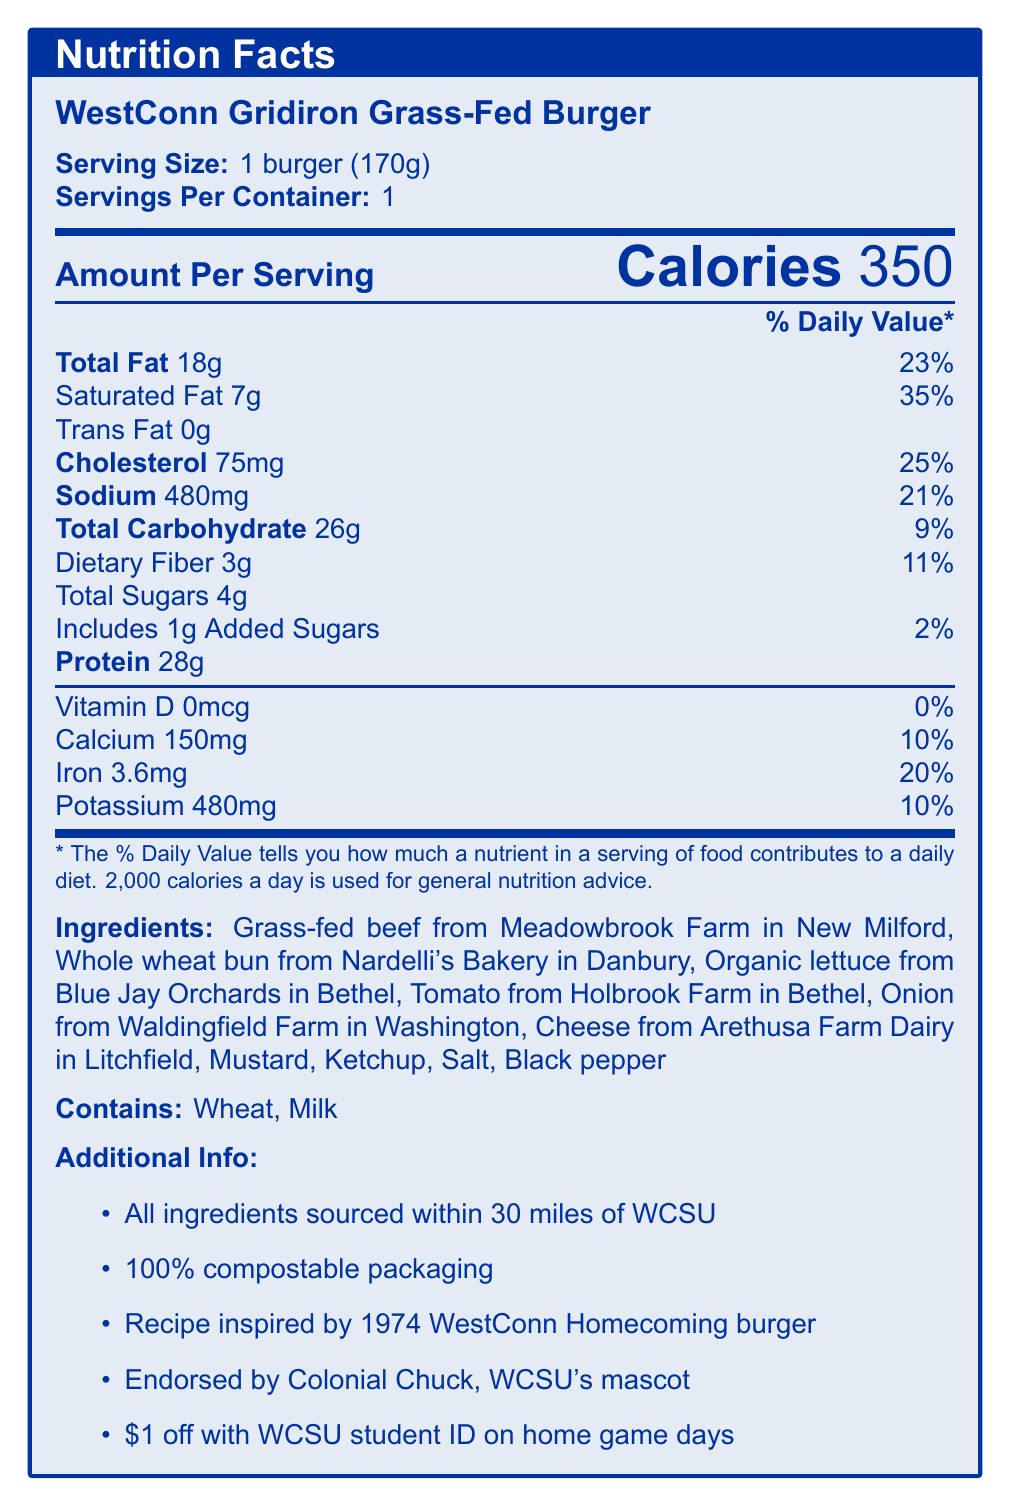what is the serving size of the WestConn Gridiron Grass-Fed Burger? The document states that the serving size is 1 burger weighing 170 grams.
Answer: 1 burger (170g) how many calories are in one serving of the WestConn Gridiron Grass-Fed Burger? The document indicates there are 350 calories in one serving.
Answer: 350 how much total fat does the burger contain? The document lists the total fat content as 18 grams.
Answer: 18g what are the ingredients of the WestConn Gridiron Grass-Fed Burger? The document details all the ingredients used in the burger.
Answer: Grass-fed beef from Meadowbrook Farm in New Milford, Whole wheat bun from Nardelli's Bakery in Danbury, Organic lettuce from Blue Jay Orchards in Bethel, Tomato from Holbrook Farm in Bethel, Onion from Waldingfield Farm in Washington, Cheese from Arethusa Farm Dairy in Litchfield, Mustard, Ketchup, Salt, Black pepper what allergens are present in the WestConn Gridiron Grass-Fed Burger? The document specifies that the allergens in the burger are wheat and milk.
Answer: Wheat, Milk how much protein does the burger contain per serving? The document provides the amount of protein per serving, which is 28 grams.
Answer: 28g what percentage of the daily value of saturated fat does the burger provide? A. 23% B. 35% C. 21% D. 2% The document indicates that the saturated fat content is 7 grams, which is 35% of the daily value.
Answer: B. 35% how many grams of dietary fiber are in the burger? A. 1g B. 2g C. 3g D. 4g The document states that the burger contains 3 grams of dietary fiber.
Answer: C. 3g is the packaging of the WestConn Gridiron Grass-Fed Burger environmentally friendly? The document mentions that the packaging is 100% compostable, which indicates it's environmentally friendly.
Answer: Yes are all ingredients sourced from a local farm within a 30-mile radius of Western Connecticut State University? The document clearly states that all ingredients are sourced within a 30-mile radius of WCSU.
Answer: Yes summarize the main info provided in the document. This summary encompasses serving size, nutritional value, ingredient sourcing, packaging sustainability, tradition, and special game day discounts, giving a comprehensive view of the document.
Answer: The document provides detailed nutrition facts for the WestConn Gridiron Grass-Fed Burger, including serving size, calories, and contents of various nutrients. It lists the ingredients, specifies allergens, mentions environmental aspects like compostable packaging, highlights the local sourcing of ingredients, and hints at the cultural significance tied to WestConn football traditions. does the document specify the type of cheese used in the burger? The document mentions the cheese is from Arethusa Farm Dairy in Litchfield but does not specify the type of cheese used.
Answer: No, only the source (Arethusa Farm Dairy in Litchfield) is mentioned. 